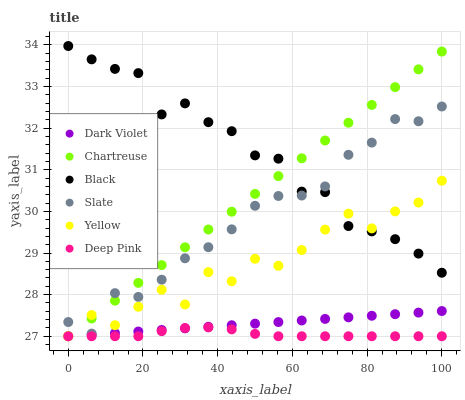Does Deep Pink have the minimum area under the curve?
Answer yes or no. Yes. Does Black have the maximum area under the curve?
Answer yes or no. Yes. Does Slate have the minimum area under the curve?
Answer yes or no. No. Does Slate have the maximum area under the curve?
Answer yes or no. No. Is Dark Violet the smoothest?
Answer yes or no. Yes. Is Yellow the roughest?
Answer yes or no. Yes. Is Slate the smoothest?
Answer yes or no. No. Is Slate the roughest?
Answer yes or no. No. Does Deep Pink have the lowest value?
Answer yes or no. Yes. Does Slate have the lowest value?
Answer yes or no. No. Does Black have the highest value?
Answer yes or no. Yes. Does Slate have the highest value?
Answer yes or no. No. Is Dark Violet less than Black?
Answer yes or no. Yes. Is Slate greater than Dark Violet?
Answer yes or no. Yes. Does Slate intersect Chartreuse?
Answer yes or no. Yes. Is Slate less than Chartreuse?
Answer yes or no. No. Is Slate greater than Chartreuse?
Answer yes or no. No. Does Dark Violet intersect Black?
Answer yes or no. No. 